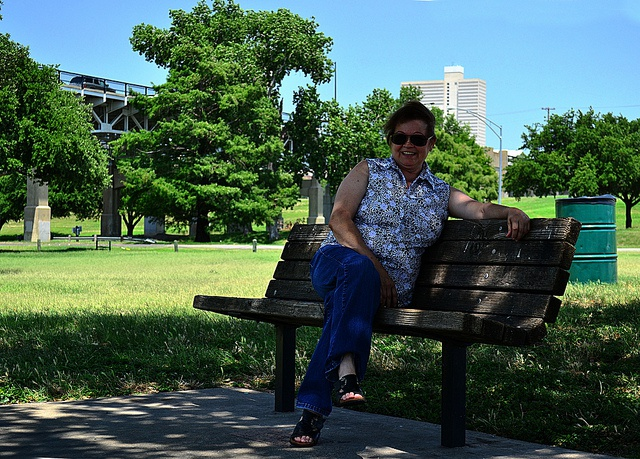Describe the objects in this image and their specific colors. I can see bench in teal, black, gray, and darkgray tones, people in teal, black, gray, and navy tones, car in teal, black, and gray tones, bench in teal, gray, black, green, and lightgray tones, and people in teal, black, darkgreen, gray, and navy tones in this image. 